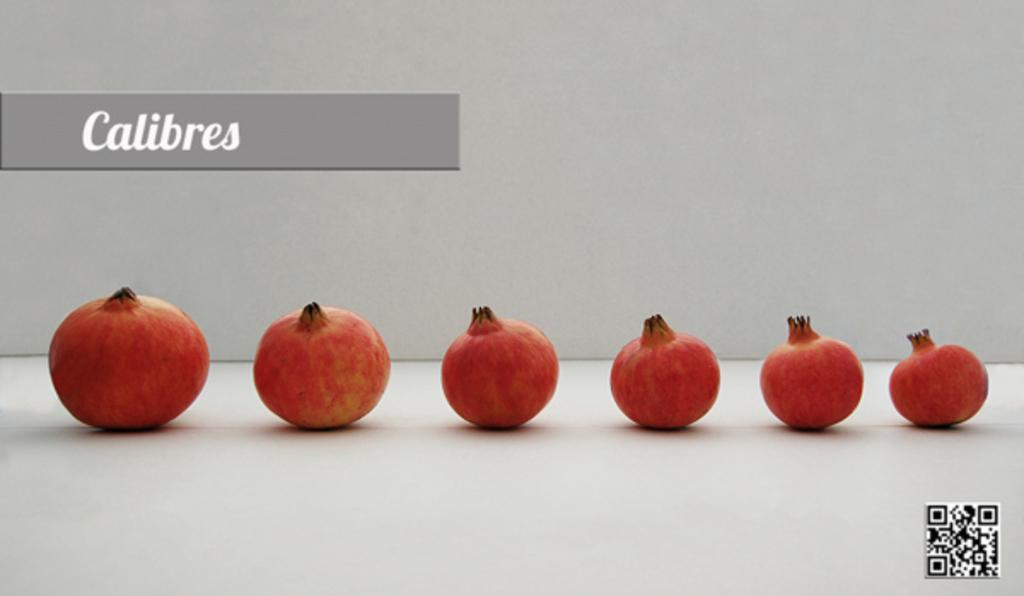What type of fruit can be seen on the table in the image? There are pomegranates on the table in the image. What is located at the bottom of the image? There is a logo at the bottom of the image. What is written or displayed at the top of the image? There is some text at the top of the image. Where is the tramp located in the image? There is no tramp present in the image. What type of brush is used to paint the pomegranates in the image? The image is a photograph, not a painting, so there is no brush used to depict the pomegranates. 